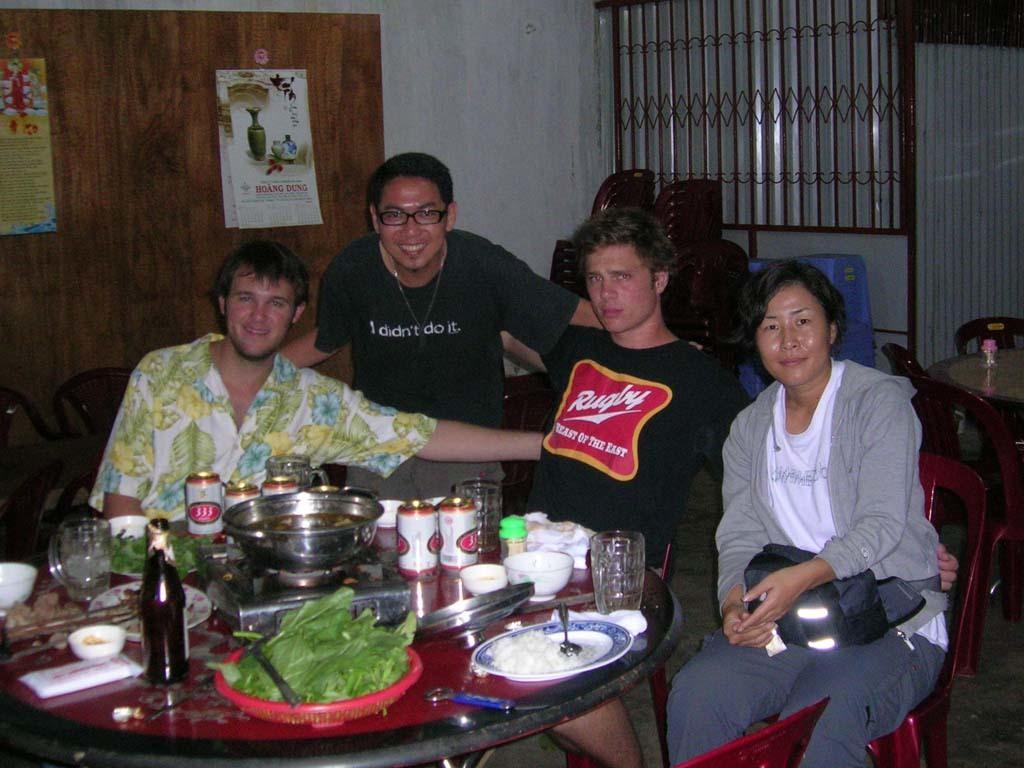Can you describe this image briefly? There are four people in front of a table which has some eatables and drinks on it. 